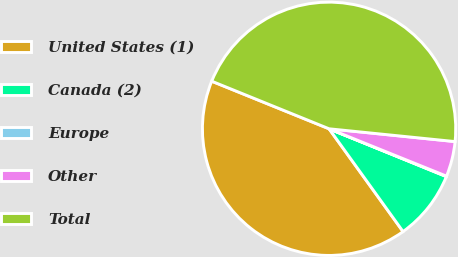Convert chart. <chart><loc_0><loc_0><loc_500><loc_500><pie_chart><fcel>United States (1)<fcel>Canada (2)<fcel>Europe<fcel>Other<fcel>Total<nl><fcel>41.06%<fcel>8.91%<fcel>0.06%<fcel>4.49%<fcel>45.48%<nl></chart> 